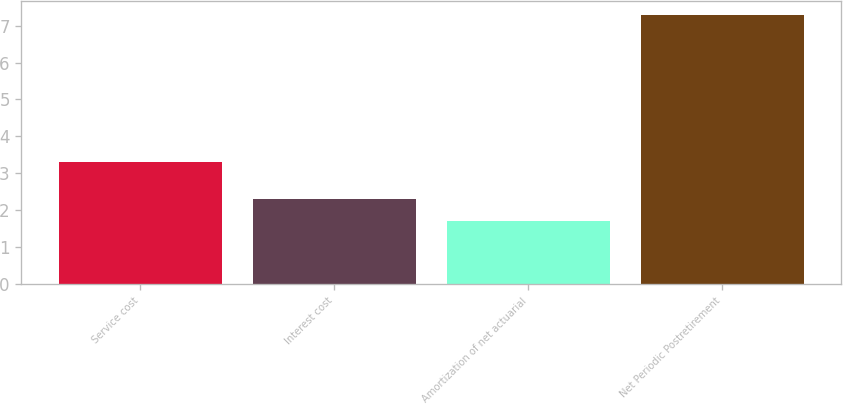Convert chart to OTSL. <chart><loc_0><loc_0><loc_500><loc_500><bar_chart><fcel>Service cost<fcel>Interest cost<fcel>Amortization of net actuarial<fcel>Net Periodic Postretirement<nl><fcel>3.3<fcel>2.3<fcel>1.7<fcel>7.3<nl></chart> 